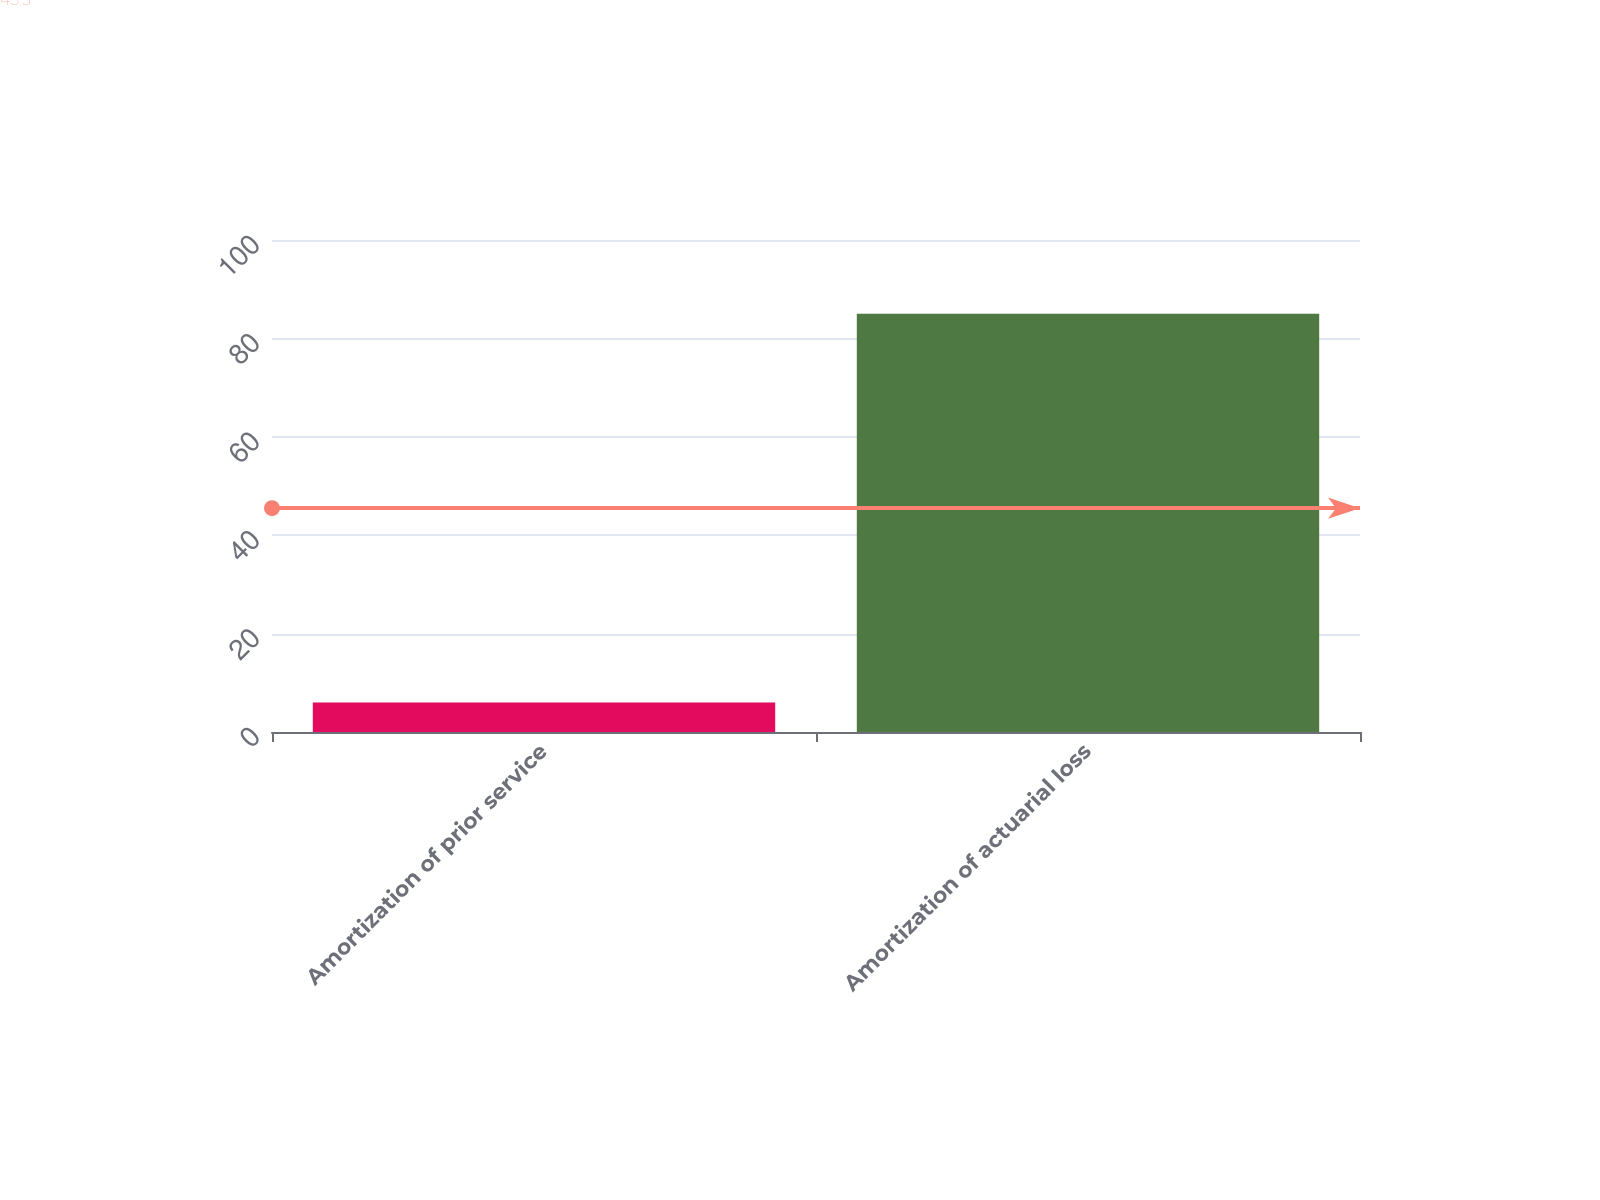<chart> <loc_0><loc_0><loc_500><loc_500><bar_chart><fcel>Amortization of prior service<fcel>Amortization of actuarial loss<nl><fcel>6<fcel>85<nl></chart> 